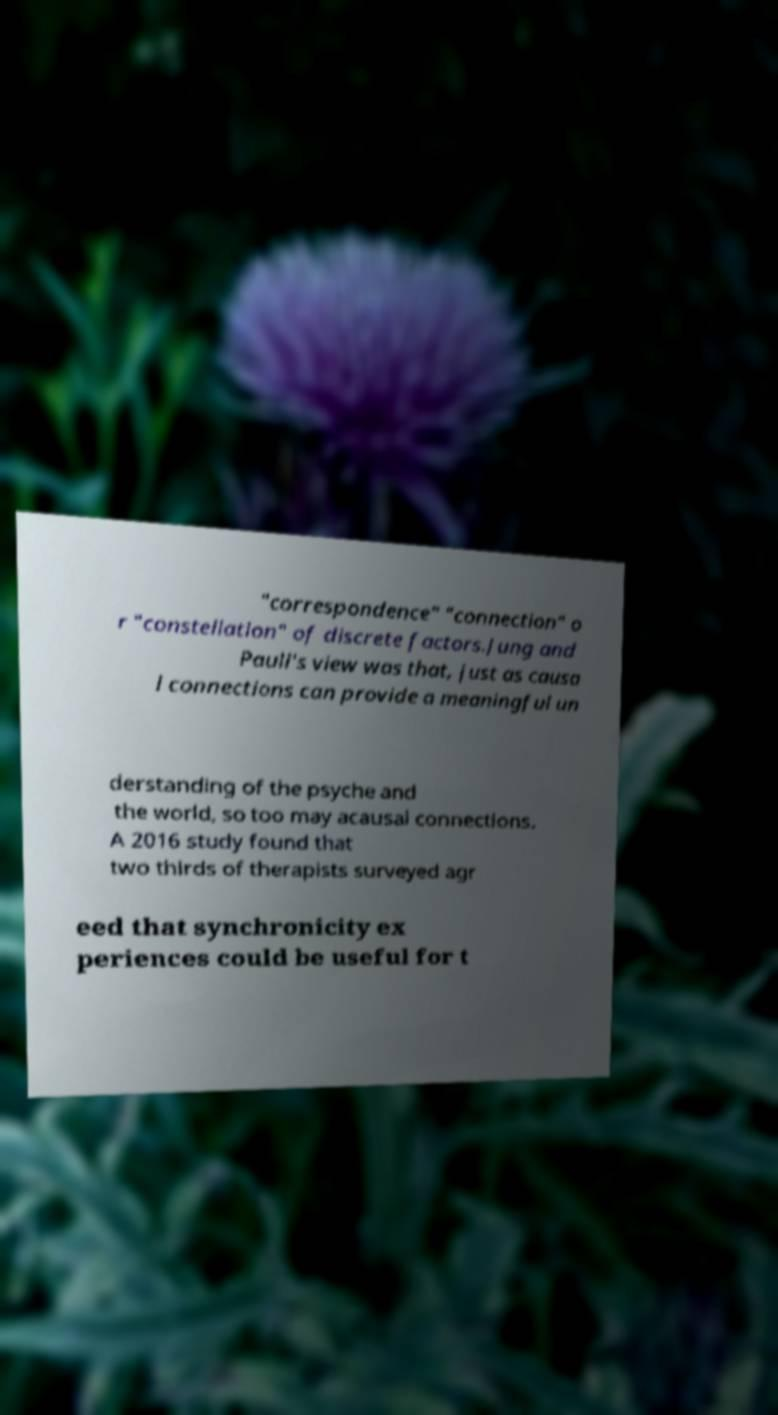Please identify and transcribe the text found in this image. "correspondence" "connection" o r "constellation" of discrete factors.Jung and Pauli's view was that, just as causa l connections can provide a meaningful un derstanding of the psyche and the world, so too may acausal connections. A 2016 study found that two thirds of therapists surveyed agr eed that synchronicity ex periences could be useful for t 